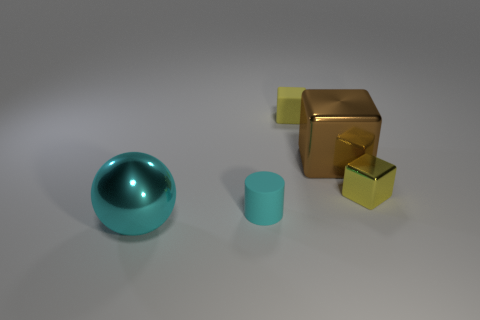There is a sphere; is its size the same as the yellow block to the right of the tiny yellow rubber cube?
Keep it short and to the point. No. Is there a large cyan shiny ball on the right side of the big thing behind the big ball?
Provide a succinct answer. No. There is a thing that is left of the small matte cube and on the right side of the ball; what is its material?
Give a very brief answer. Rubber. There is a matte object that is behind the small thing that is to the right of the yellow block that is left of the big brown metal block; what is its color?
Provide a short and direct response. Yellow. The matte cube that is the same size as the cyan cylinder is what color?
Offer a terse response. Yellow. Do the big block and the object that is left of the small cyan matte cylinder have the same color?
Your response must be concise. No. There is a tiny yellow thing on the right side of the yellow block on the left side of the large brown shiny block; what is its material?
Your response must be concise. Metal. What number of objects are both to the left of the cyan cylinder and behind the large brown metal block?
Your answer should be very brief. 0. How many other objects are there of the same size as the brown metal cube?
Ensure brevity in your answer.  1. There is a cyan object behind the large cyan thing; is its shape the same as the small yellow thing behind the large brown metallic block?
Your answer should be compact. No. 